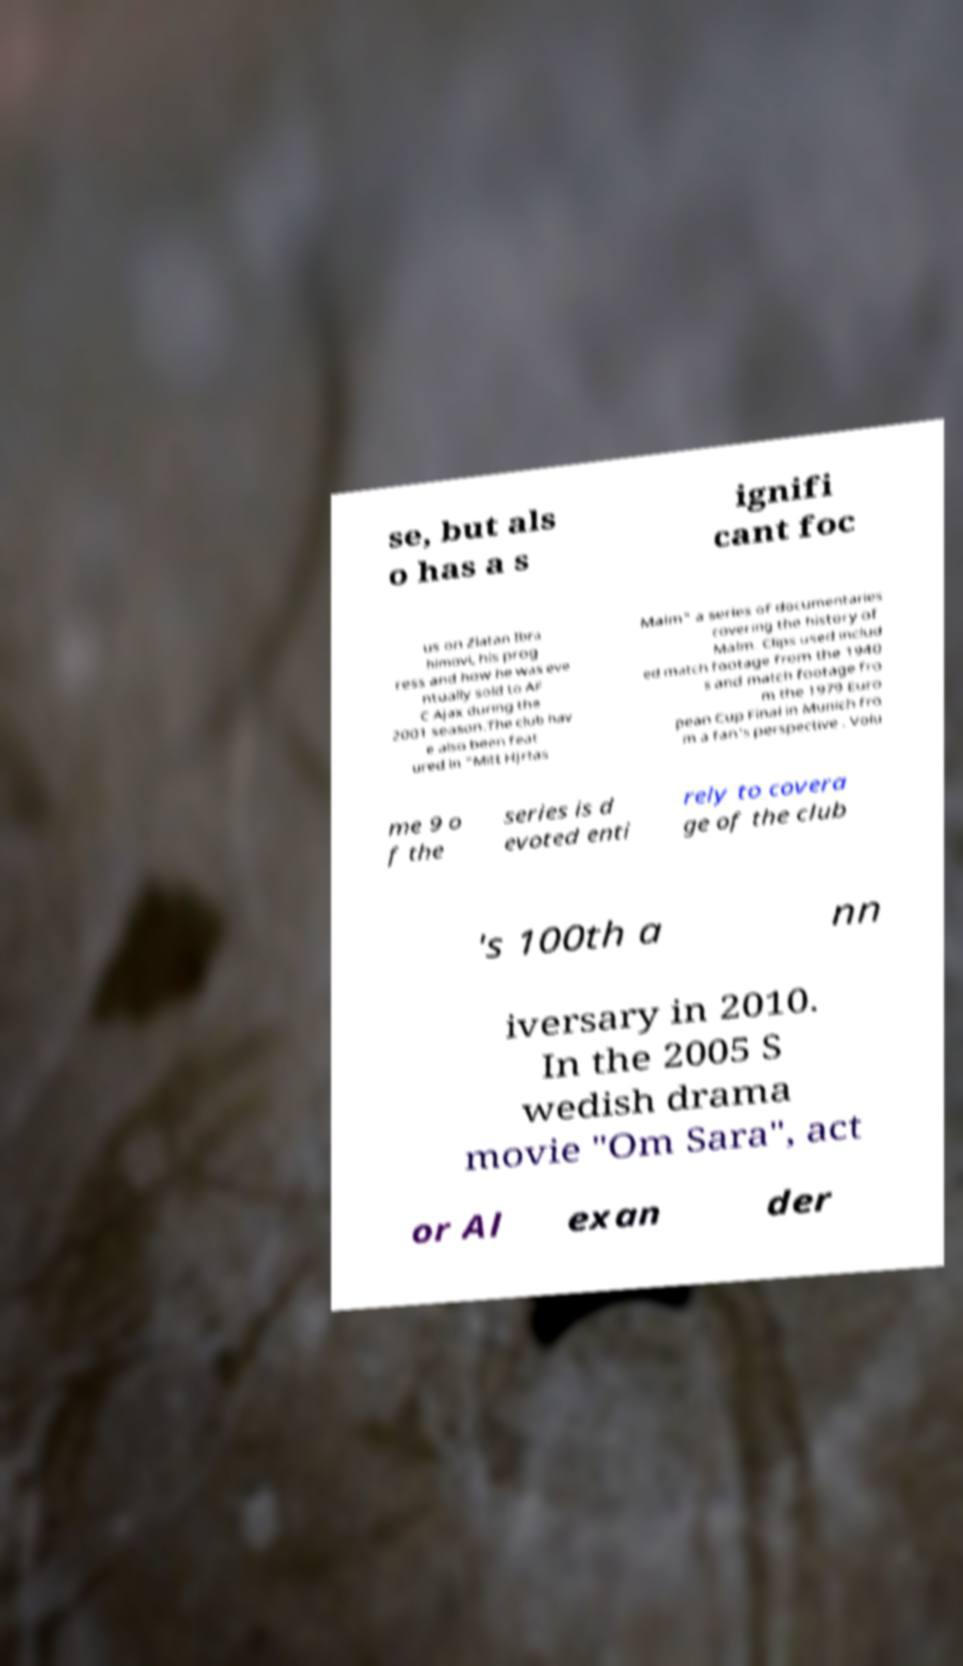Can you accurately transcribe the text from the provided image for me? se, but als o has a s ignifi cant foc us on Zlatan Ibra himovi, his prog ress and how he was eve ntually sold to AF C Ajax during the 2001 season.The club hav e also been feat ured in "Mitt Hjrtas Malm" a series of documentaries covering the history of Malm. Clips used includ ed match footage from the 1940 s and match footage fro m the 1979 Euro pean Cup Final in Munich fro m a fan's perspective . Volu me 9 o f the series is d evoted enti rely to covera ge of the club 's 100th a nn iversary in 2010. In the 2005 S wedish drama movie "Om Sara", act or Al exan der 